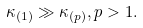<formula> <loc_0><loc_0><loc_500><loc_500>\kappa _ { ( 1 ) } \gg \kappa _ { ( p ) } , p > 1 .</formula> 